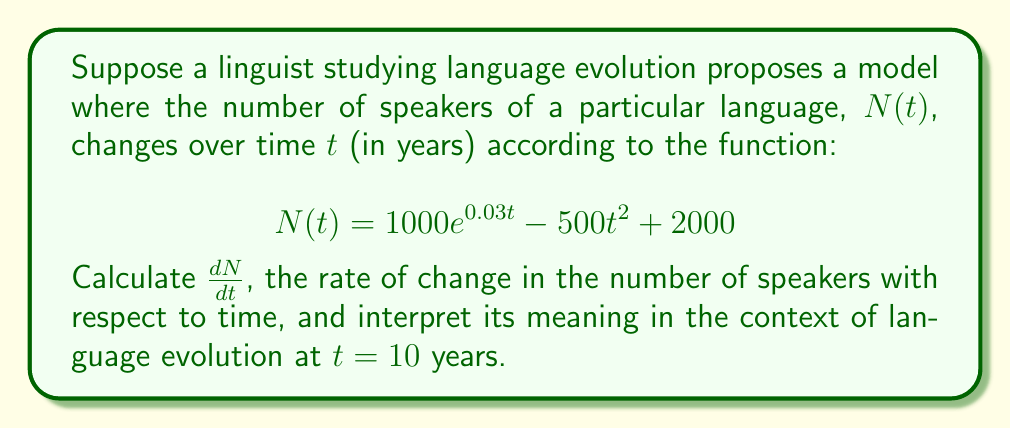Can you solve this math problem? To solve this problem, we need to follow these steps:

1) First, we need to find the derivative of $N(t)$ with respect to $t$. We'll use the sum and difference rules of differentiation, along with the chain rule for the exponential term.

2) The function $N(t)$ consists of three terms:
   - $1000e^{0.03t}$
   - $-500t^2$
   - $2000$

3) Let's differentiate each term:
   - For $1000e^{0.03t}$: $\frac{d}{dt}(1000e^{0.03t}) = 1000 \cdot 0.03e^{0.03t} = 30e^{0.03t}$
   - For $-500t^2$: $\frac{d}{dt}(-500t^2) = -1000t$
   - For $2000$: $\frac{d}{dt}(2000) = 0$

4) Combining these results:

   $$\frac{dN}{dt} = 30e^{0.03t} - 1000t$$

5) To interpret this at $t = 10$ years, we substitute $t = 10$ into our derivative:

   $$\frac{dN}{dt}|_{t=10} = 30e^{0.3} - 1000(10) = 30 \cdot 1.35 - 10000 \approx -9959.5$$

6) Interpretation: At $t = 10$ years, the rate of change in the number of speakers is approximately -9959.5 speakers per year. The negative value indicates that the number of speakers is decreasing at this point in time. This could represent a declining phase in the language's evolution, possibly due to factors such as language shift, cultural changes, or demographic trends affecting the speaker population.
Answer: $\frac{dN}{dt} = 30e^{0.03t} - 1000t$

At $t = 10$ years, $\frac{dN}{dt} \approx -9959.5$ speakers per year, indicating a declining trend in the number of speakers at that point in time. 